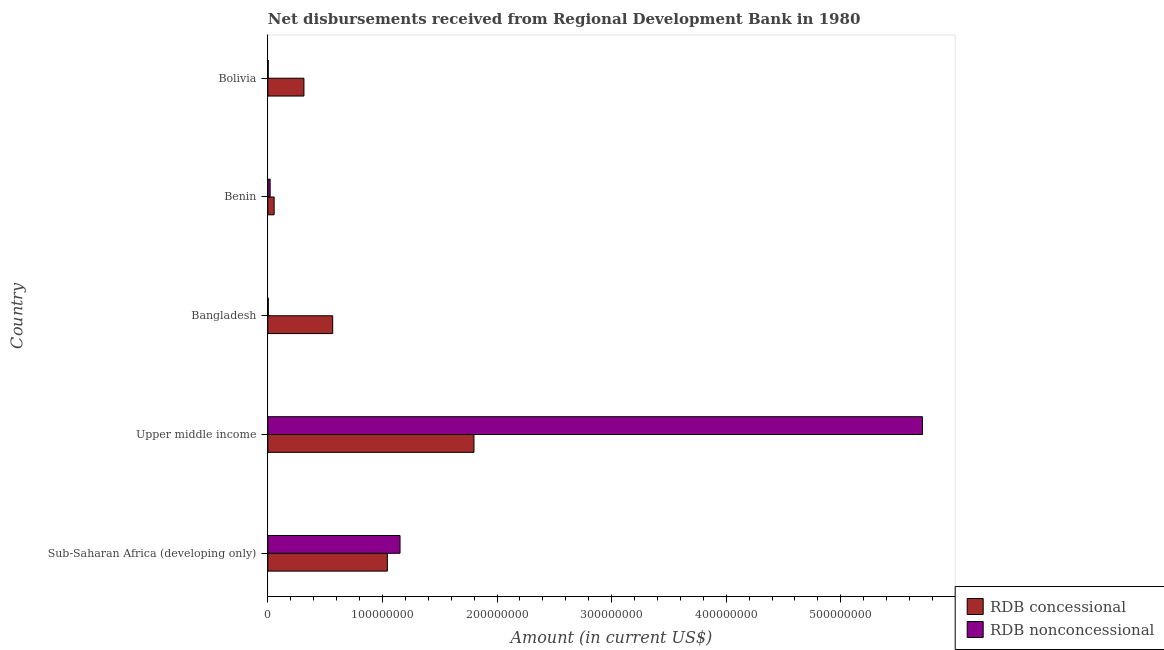How many different coloured bars are there?
Keep it short and to the point. 2. How many groups of bars are there?
Keep it short and to the point. 5. Are the number of bars on each tick of the Y-axis equal?
Give a very brief answer. Yes. How many bars are there on the 3rd tick from the bottom?
Provide a succinct answer. 2. What is the label of the 1st group of bars from the top?
Keep it short and to the point. Bolivia. What is the net concessional disbursements from rdb in Bangladesh?
Provide a succinct answer. 5.66e+07. Across all countries, what is the maximum net non concessional disbursements from rdb?
Give a very brief answer. 5.71e+08. Across all countries, what is the minimum net non concessional disbursements from rdb?
Give a very brief answer. 3.34e+05. In which country was the net concessional disbursements from rdb maximum?
Make the answer very short. Upper middle income. In which country was the net non concessional disbursements from rdb minimum?
Your answer should be compact. Bolivia. What is the total net concessional disbursements from rdb in the graph?
Provide a short and direct response. 3.78e+08. What is the difference between the net concessional disbursements from rdb in Bolivia and that in Sub-Saharan Africa (developing only)?
Provide a short and direct response. -7.28e+07. What is the difference between the net concessional disbursements from rdb in Benin and the net non concessional disbursements from rdb in Sub-Saharan Africa (developing only)?
Your answer should be very brief. -1.10e+08. What is the average net concessional disbursements from rdb per country?
Offer a very short reply. 7.56e+07. What is the difference between the net non concessional disbursements from rdb and net concessional disbursements from rdb in Sub-Saharan Africa (developing only)?
Provide a short and direct response. 1.10e+07. What is the ratio of the net non concessional disbursements from rdb in Bangladesh to that in Benin?
Make the answer very short. 0.19. Is the difference between the net non concessional disbursements from rdb in Benin and Upper middle income greater than the difference between the net concessional disbursements from rdb in Benin and Upper middle income?
Keep it short and to the point. No. What is the difference between the highest and the second highest net concessional disbursements from rdb?
Offer a very short reply. 7.56e+07. What is the difference between the highest and the lowest net concessional disbursements from rdb?
Your answer should be very brief. 1.74e+08. In how many countries, is the net non concessional disbursements from rdb greater than the average net non concessional disbursements from rdb taken over all countries?
Your answer should be very brief. 1. Is the sum of the net non concessional disbursements from rdb in Bangladesh and Upper middle income greater than the maximum net concessional disbursements from rdb across all countries?
Keep it short and to the point. Yes. What does the 2nd bar from the top in Sub-Saharan Africa (developing only) represents?
Provide a succinct answer. RDB concessional. What does the 1st bar from the bottom in Sub-Saharan Africa (developing only) represents?
Offer a terse response. RDB concessional. Are all the bars in the graph horizontal?
Your response must be concise. Yes. How many countries are there in the graph?
Offer a very short reply. 5. What is the difference between two consecutive major ticks on the X-axis?
Provide a short and direct response. 1.00e+08. Where does the legend appear in the graph?
Give a very brief answer. Bottom right. How are the legend labels stacked?
Make the answer very short. Vertical. What is the title of the graph?
Ensure brevity in your answer.  Net disbursements received from Regional Development Bank in 1980. What is the Amount (in current US$) of RDB concessional in Sub-Saharan Africa (developing only)?
Your answer should be compact. 1.04e+08. What is the Amount (in current US$) of RDB nonconcessional in Sub-Saharan Africa (developing only)?
Ensure brevity in your answer.  1.15e+08. What is the Amount (in current US$) of RDB concessional in Upper middle income?
Give a very brief answer. 1.80e+08. What is the Amount (in current US$) in RDB nonconcessional in Upper middle income?
Keep it short and to the point. 5.71e+08. What is the Amount (in current US$) in RDB concessional in Bangladesh?
Your response must be concise. 5.66e+07. What is the Amount (in current US$) of RDB concessional in Benin?
Provide a succinct answer. 5.50e+06. What is the Amount (in current US$) of RDB nonconcessional in Benin?
Make the answer very short. 2.00e+06. What is the Amount (in current US$) in RDB concessional in Bolivia?
Make the answer very short. 3.15e+07. What is the Amount (in current US$) of RDB nonconcessional in Bolivia?
Provide a short and direct response. 3.34e+05. Across all countries, what is the maximum Amount (in current US$) in RDB concessional?
Provide a short and direct response. 1.80e+08. Across all countries, what is the maximum Amount (in current US$) of RDB nonconcessional?
Make the answer very short. 5.71e+08. Across all countries, what is the minimum Amount (in current US$) of RDB concessional?
Your answer should be compact. 5.50e+06. Across all countries, what is the minimum Amount (in current US$) of RDB nonconcessional?
Keep it short and to the point. 3.34e+05. What is the total Amount (in current US$) of RDB concessional in the graph?
Make the answer very short. 3.78e+08. What is the total Amount (in current US$) of RDB nonconcessional in the graph?
Your answer should be compact. 6.89e+08. What is the difference between the Amount (in current US$) in RDB concessional in Sub-Saharan Africa (developing only) and that in Upper middle income?
Offer a very short reply. -7.56e+07. What is the difference between the Amount (in current US$) of RDB nonconcessional in Sub-Saharan Africa (developing only) and that in Upper middle income?
Give a very brief answer. -4.56e+08. What is the difference between the Amount (in current US$) in RDB concessional in Sub-Saharan Africa (developing only) and that in Bangladesh?
Make the answer very short. 4.77e+07. What is the difference between the Amount (in current US$) in RDB nonconcessional in Sub-Saharan Africa (developing only) and that in Bangladesh?
Keep it short and to the point. 1.15e+08. What is the difference between the Amount (in current US$) in RDB concessional in Sub-Saharan Africa (developing only) and that in Benin?
Give a very brief answer. 9.88e+07. What is the difference between the Amount (in current US$) of RDB nonconcessional in Sub-Saharan Africa (developing only) and that in Benin?
Keep it short and to the point. 1.13e+08. What is the difference between the Amount (in current US$) in RDB concessional in Sub-Saharan Africa (developing only) and that in Bolivia?
Offer a terse response. 7.28e+07. What is the difference between the Amount (in current US$) of RDB nonconcessional in Sub-Saharan Africa (developing only) and that in Bolivia?
Offer a very short reply. 1.15e+08. What is the difference between the Amount (in current US$) in RDB concessional in Upper middle income and that in Bangladesh?
Ensure brevity in your answer.  1.23e+08. What is the difference between the Amount (in current US$) in RDB nonconcessional in Upper middle income and that in Bangladesh?
Your response must be concise. 5.71e+08. What is the difference between the Amount (in current US$) of RDB concessional in Upper middle income and that in Benin?
Provide a short and direct response. 1.74e+08. What is the difference between the Amount (in current US$) of RDB nonconcessional in Upper middle income and that in Benin?
Ensure brevity in your answer.  5.69e+08. What is the difference between the Amount (in current US$) in RDB concessional in Upper middle income and that in Bolivia?
Your answer should be very brief. 1.48e+08. What is the difference between the Amount (in current US$) of RDB nonconcessional in Upper middle income and that in Bolivia?
Ensure brevity in your answer.  5.71e+08. What is the difference between the Amount (in current US$) of RDB concessional in Bangladesh and that in Benin?
Ensure brevity in your answer.  5.11e+07. What is the difference between the Amount (in current US$) of RDB nonconcessional in Bangladesh and that in Benin?
Offer a terse response. -1.62e+06. What is the difference between the Amount (in current US$) of RDB concessional in Bangladesh and that in Bolivia?
Give a very brief answer. 2.51e+07. What is the difference between the Amount (in current US$) in RDB nonconcessional in Bangladesh and that in Bolivia?
Your answer should be very brief. 4.60e+04. What is the difference between the Amount (in current US$) of RDB concessional in Benin and that in Bolivia?
Provide a short and direct response. -2.60e+07. What is the difference between the Amount (in current US$) in RDB nonconcessional in Benin and that in Bolivia?
Provide a short and direct response. 1.67e+06. What is the difference between the Amount (in current US$) of RDB concessional in Sub-Saharan Africa (developing only) and the Amount (in current US$) of RDB nonconcessional in Upper middle income?
Your answer should be compact. -4.67e+08. What is the difference between the Amount (in current US$) of RDB concessional in Sub-Saharan Africa (developing only) and the Amount (in current US$) of RDB nonconcessional in Bangladesh?
Make the answer very short. 1.04e+08. What is the difference between the Amount (in current US$) of RDB concessional in Sub-Saharan Africa (developing only) and the Amount (in current US$) of RDB nonconcessional in Benin?
Provide a short and direct response. 1.02e+08. What is the difference between the Amount (in current US$) of RDB concessional in Sub-Saharan Africa (developing only) and the Amount (in current US$) of RDB nonconcessional in Bolivia?
Make the answer very short. 1.04e+08. What is the difference between the Amount (in current US$) in RDB concessional in Upper middle income and the Amount (in current US$) in RDB nonconcessional in Bangladesh?
Make the answer very short. 1.80e+08. What is the difference between the Amount (in current US$) in RDB concessional in Upper middle income and the Amount (in current US$) in RDB nonconcessional in Benin?
Your answer should be compact. 1.78e+08. What is the difference between the Amount (in current US$) in RDB concessional in Upper middle income and the Amount (in current US$) in RDB nonconcessional in Bolivia?
Make the answer very short. 1.80e+08. What is the difference between the Amount (in current US$) in RDB concessional in Bangladesh and the Amount (in current US$) in RDB nonconcessional in Benin?
Offer a terse response. 5.46e+07. What is the difference between the Amount (in current US$) of RDB concessional in Bangladesh and the Amount (in current US$) of RDB nonconcessional in Bolivia?
Offer a very short reply. 5.63e+07. What is the difference between the Amount (in current US$) in RDB concessional in Benin and the Amount (in current US$) in RDB nonconcessional in Bolivia?
Make the answer very short. 5.16e+06. What is the average Amount (in current US$) of RDB concessional per country?
Provide a short and direct response. 7.56e+07. What is the average Amount (in current US$) in RDB nonconcessional per country?
Provide a short and direct response. 1.38e+08. What is the difference between the Amount (in current US$) of RDB concessional and Amount (in current US$) of RDB nonconcessional in Sub-Saharan Africa (developing only)?
Keep it short and to the point. -1.10e+07. What is the difference between the Amount (in current US$) of RDB concessional and Amount (in current US$) of RDB nonconcessional in Upper middle income?
Give a very brief answer. -3.91e+08. What is the difference between the Amount (in current US$) of RDB concessional and Amount (in current US$) of RDB nonconcessional in Bangladesh?
Ensure brevity in your answer.  5.62e+07. What is the difference between the Amount (in current US$) in RDB concessional and Amount (in current US$) in RDB nonconcessional in Benin?
Provide a short and direct response. 3.49e+06. What is the difference between the Amount (in current US$) in RDB concessional and Amount (in current US$) in RDB nonconcessional in Bolivia?
Offer a very short reply. 3.12e+07. What is the ratio of the Amount (in current US$) of RDB concessional in Sub-Saharan Africa (developing only) to that in Upper middle income?
Provide a succinct answer. 0.58. What is the ratio of the Amount (in current US$) of RDB nonconcessional in Sub-Saharan Africa (developing only) to that in Upper middle income?
Provide a succinct answer. 0.2. What is the ratio of the Amount (in current US$) in RDB concessional in Sub-Saharan Africa (developing only) to that in Bangladesh?
Offer a very short reply. 1.84. What is the ratio of the Amount (in current US$) in RDB nonconcessional in Sub-Saharan Africa (developing only) to that in Bangladesh?
Keep it short and to the point. 303.57. What is the ratio of the Amount (in current US$) in RDB concessional in Sub-Saharan Africa (developing only) to that in Benin?
Your answer should be compact. 18.98. What is the ratio of the Amount (in current US$) of RDB nonconcessional in Sub-Saharan Africa (developing only) to that in Benin?
Give a very brief answer. 57.56. What is the ratio of the Amount (in current US$) of RDB concessional in Sub-Saharan Africa (developing only) to that in Bolivia?
Provide a short and direct response. 3.31. What is the ratio of the Amount (in current US$) in RDB nonconcessional in Sub-Saharan Africa (developing only) to that in Bolivia?
Make the answer very short. 345.37. What is the ratio of the Amount (in current US$) in RDB concessional in Upper middle income to that in Bangladesh?
Your answer should be very brief. 3.18. What is the ratio of the Amount (in current US$) in RDB nonconcessional in Upper middle income to that in Bangladesh?
Your answer should be compact. 1503.27. What is the ratio of the Amount (in current US$) in RDB concessional in Upper middle income to that in Benin?
Make the answer very short. 32.73. What is the ratio of the Amount (in current US$) of RDB nonconcessional in Upper middle income to that in Benin?
Give a very brief answer. 285.05. What is the ratio of the Amount (in current US$) of RDB concessional in Upper middle income to that in Bolivia?
Give a very brief answer. 5.71. What is the ratio of the Amount (in current US$) in RDB nonconcessional in Upper middle income to that in Bolivia?
Offer a very short reply. 1710.31. What is the ratio of the Amount (in current US$) of RDB concessional in Bangladesh to that in Benin?
Give a very brief answer. 10.3. What is the ratio of the Amount (in current US$) in RDB nonconcessional in Bangladesh to that in Benin?
Ensure brevity in your answer.  0.19. What is the ratio of the Amount (in current US$) of RDB concessional in Bangladesh to that in Bolivia?
Keep it short and to the point. 1.8. What is the ratio of the Amount (in current US$) of RDB nonconcessional in Bangladesh to that in Bolivia?
Offer a very short reply. 1.14. What is the ratio of the Amount (in current US$) of RDB concessional in Benin to that in Bolivia?
Ensure brevity in your answer.  0.17. What is the difference between the highest and the second highest Amount (in current US$) of RDB concessional?
Provide a short and direct response. 7.56e+07. What is the difference between the highest and the second highest Amount (in current US$) of RDB nonconcessional?
Your response must be concise. 4.56e+08. What is the difference between the highest and the lowest Amount (in current US$) in RDB concessional?
Ensure brevity in your answer.  1.74e+08. What is the difference between the highest and the lowest Amount (in current US$) of RDB nonconcessional?
Give a very brief answer. 5.71e+08. 